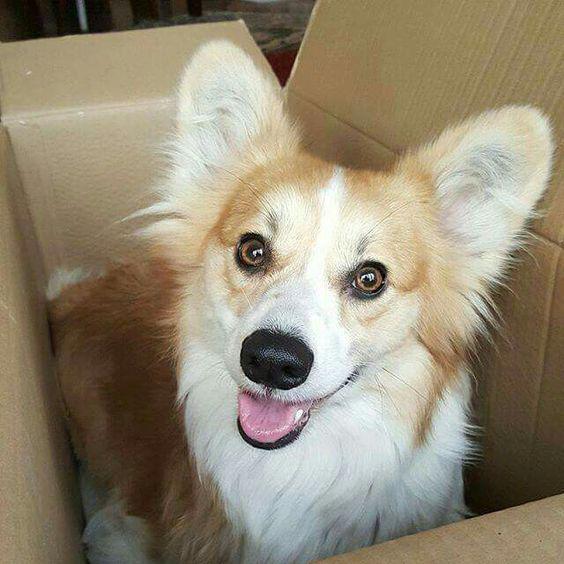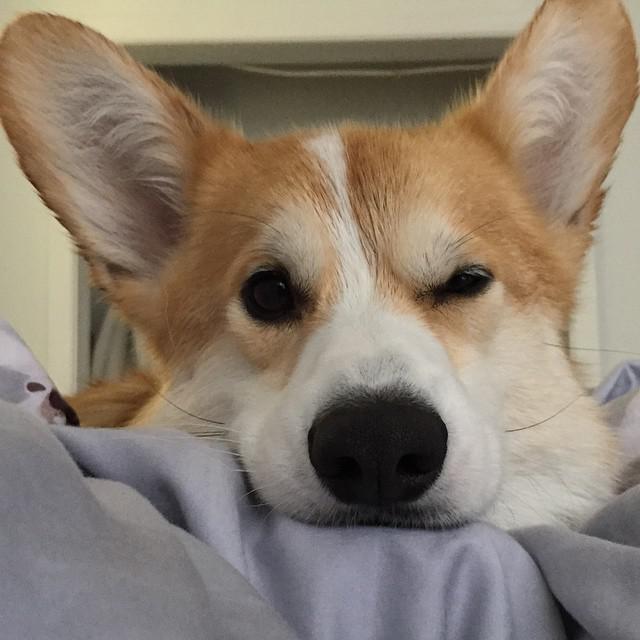The first image is the image on the left, the second image is the image on the right. For the images displayed, is the sentence "There are two adult corgis, one of which is clearly in a box." factually correct? Answer yes or no. Yes. The first image is the image on the left, the second image is the image on the right. Considering the images on both sides, is "A dog is in a brown cardboard box with its flaps folding outward instead of tucked inward." valid? Answer yes or no. Yes. 